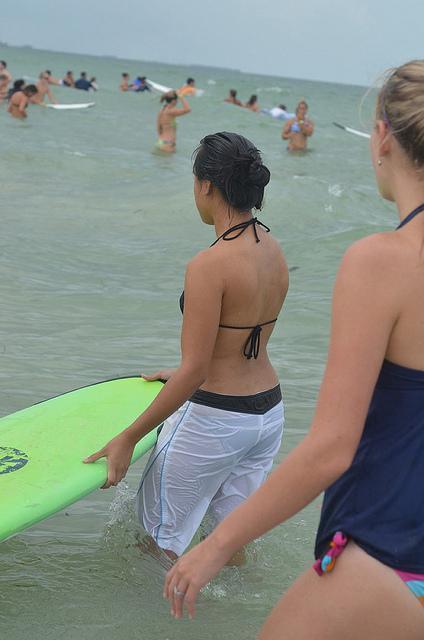How many people are in the photo?
Give a very brief answer. 2. 